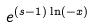Convert formula to latex. <formula><loc_0><loc_0><loc_500><loc_500>e ^ { ( s - 1 ) \ln ( - x ) }</formula> 